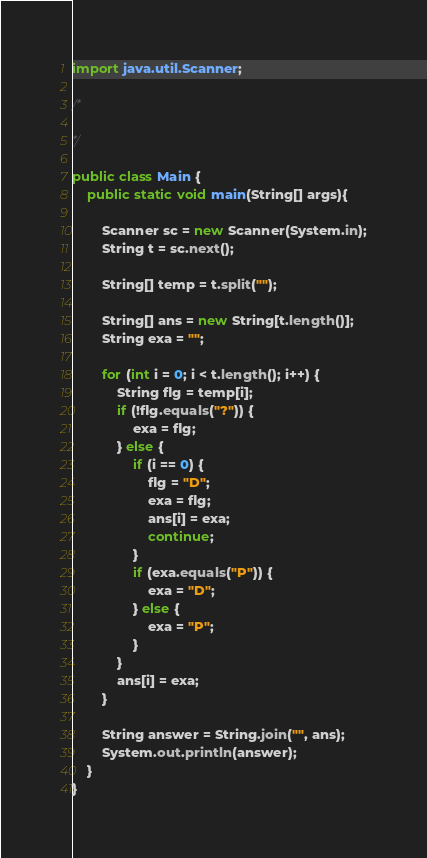Convert code to text. <code><loc_0><loc_0><loc_500><loc_500><_Java_>import java.util.Scanner;

/*

*/

public class Main {
    public static void main(String[] args){

        Scanner sc = new Scanner(System.in);
        String t = sc.next();

        String[] temp = t.split("");

        String[] ans = new String[t.length()];
        String exa = "";

        for (int i = 0; i < t.length(); i++) {
            String flg = temp[i];
            if (!flg.equals("?")) {
                exa = flg;
            } else {
                if (i == 0) {
                    flg = "D";
                    exa = flg;
                    ans[i] = exa;
                    continue;
                }
                if (exa.equals("P")) {
                    exa = "D";
                } else {
                    exa = "P";
                }    
            }
            ans[i] = exa;
        }

        String answer = String.join("", ans);
        System.out.println(answer);
    }
}</code> 